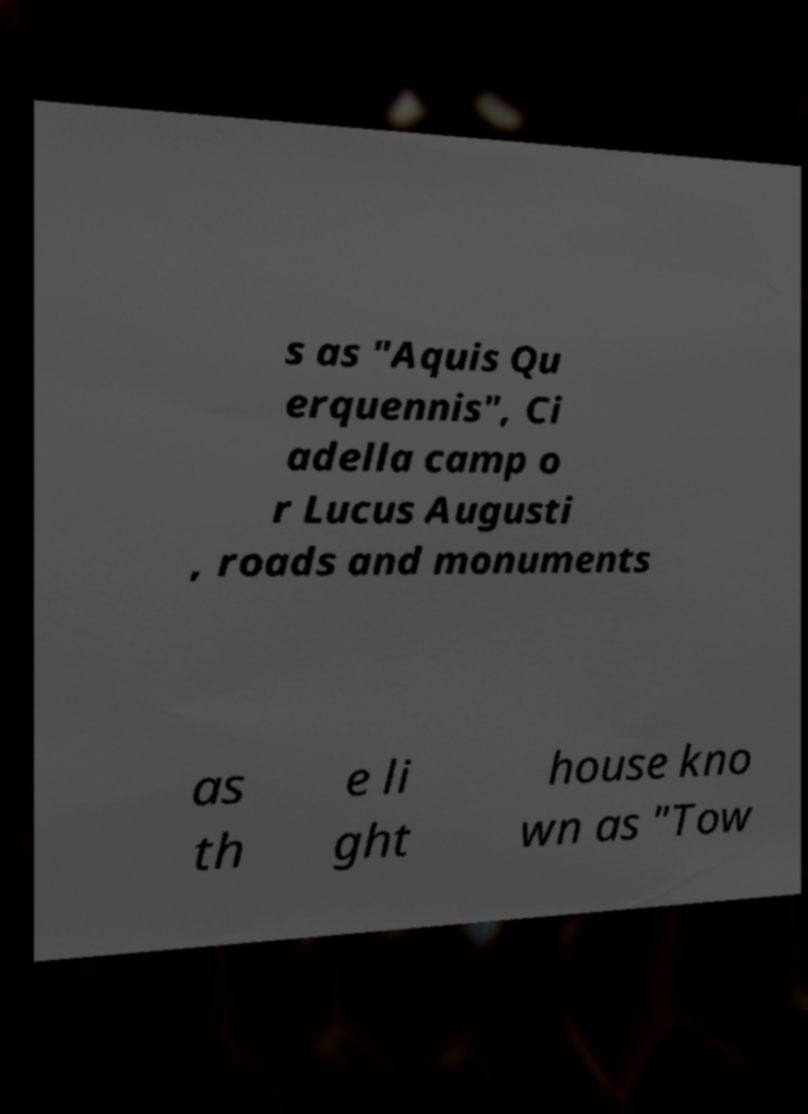Can you accurately transcribe the text from the provided image for me? s as "Aquis Qu erquennis", Ci adella camp o r Lucus Augusti , roads and monuments as th e li ght house kno wn as "Tow 